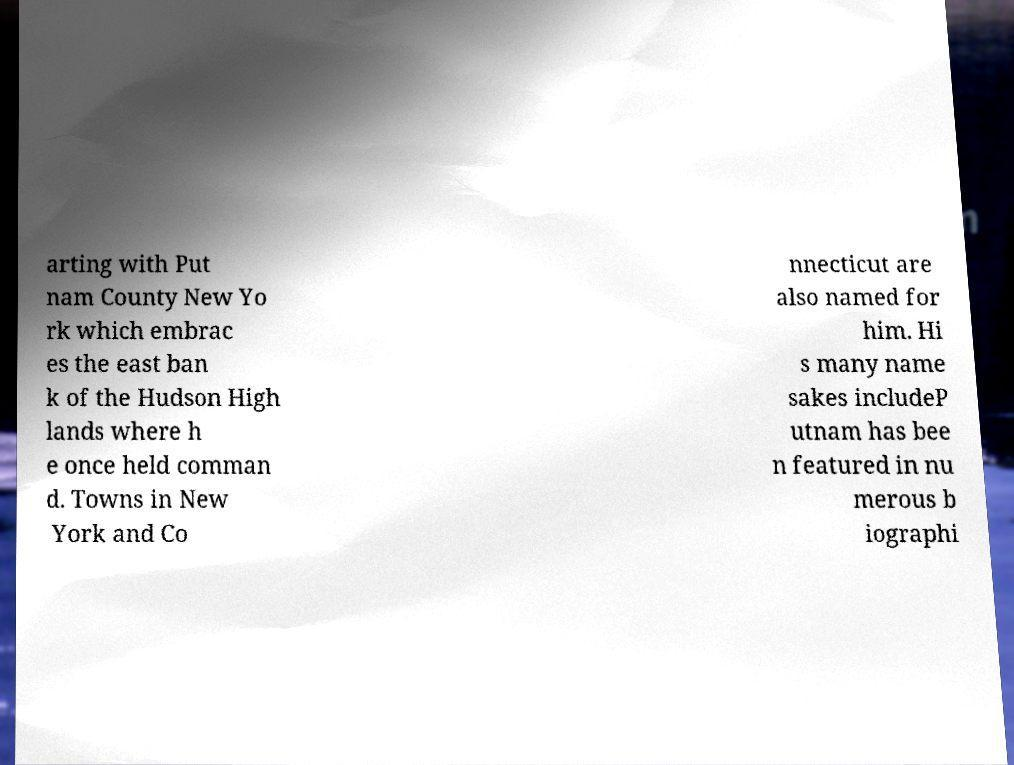What messages or text are displayed in this image? I need them in a readable, typed format. arting with Put nam County New Yo rk which embrac es the east ban k of the Hudson High lands where h e once held comman d. Towns in New York and Co nnecticut are also named for him. Hi s many name sakes includeP utnam has bee n featured in nu merous b iographi 